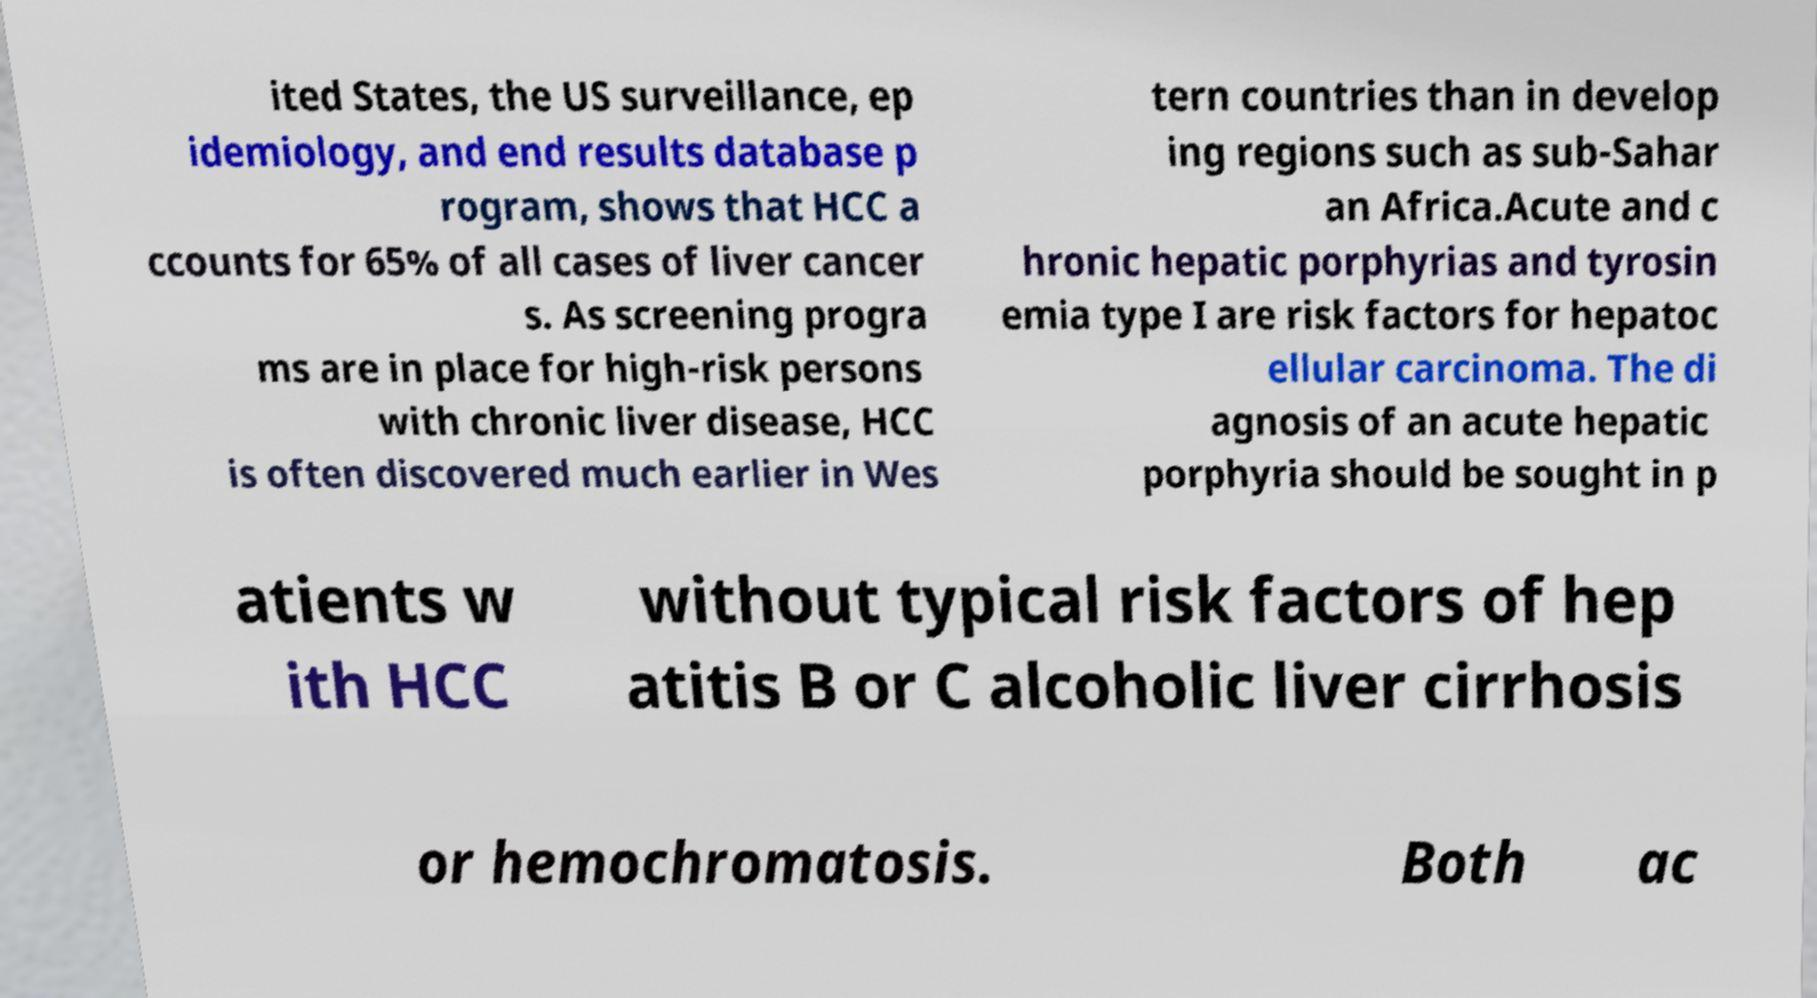Can you read and provide the text displayed in the image?This photo seems to have some interesting text. Can you extract and type it out for me? ited States, the US surveillance, ep idemiology, and end results database p rogram, shows that HCC a ccounts for 65% of all cases of liver cancer s. As screening progra ms are in place for high-risk persons with chronic liver disease, HCC is often discovered much earlier in Wes tern countries than in develop ing regions such as sub-Sahar an Africa.Acute and c hronic hepatic porphyrias and tyrosin emia type I are risk factors for hepatoc ellular carcinoma. The di agnosis of an acute hepatic porphyria should be sought in p atients w ith HCC without typical risk factors of hep atitis B or C alcoholic liver cirrhosis or hemochromatosis. Both ac 